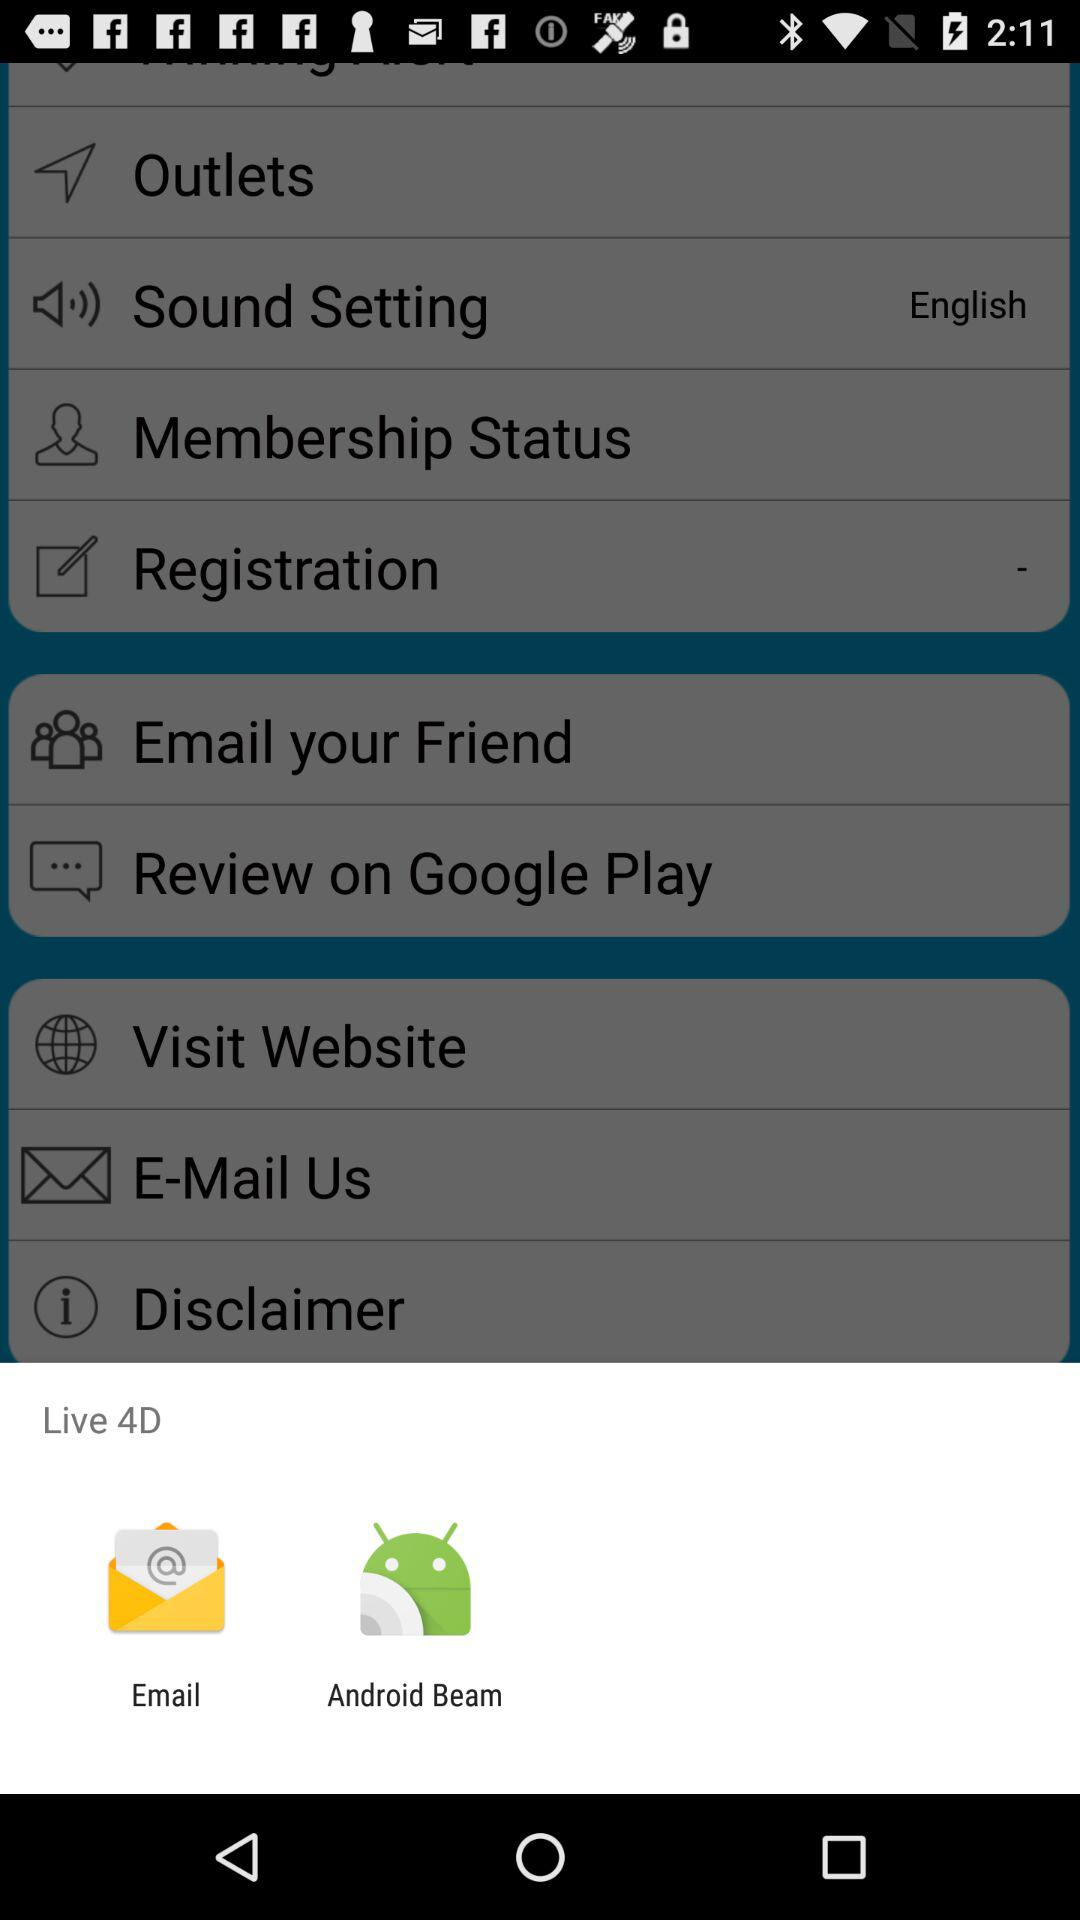What is the number of dimensions for live? The number of dimensions for live is 4. 